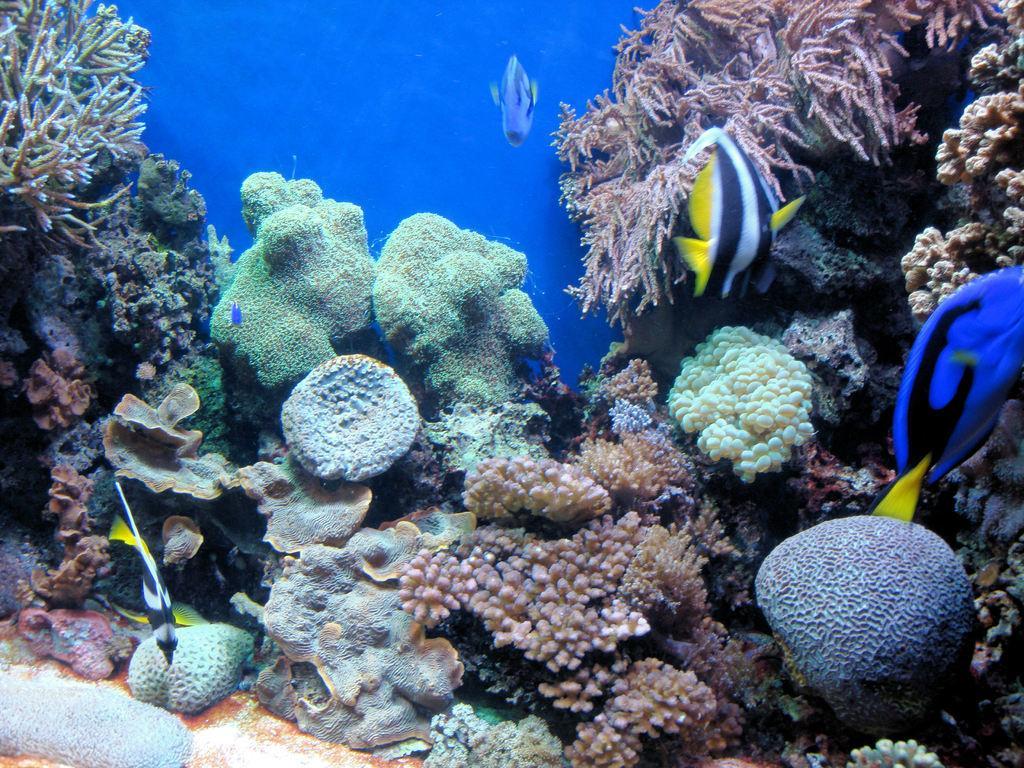Can you describe this image briefly? In this image I can see few fishes, sea plants and I can see blue colour in background. 